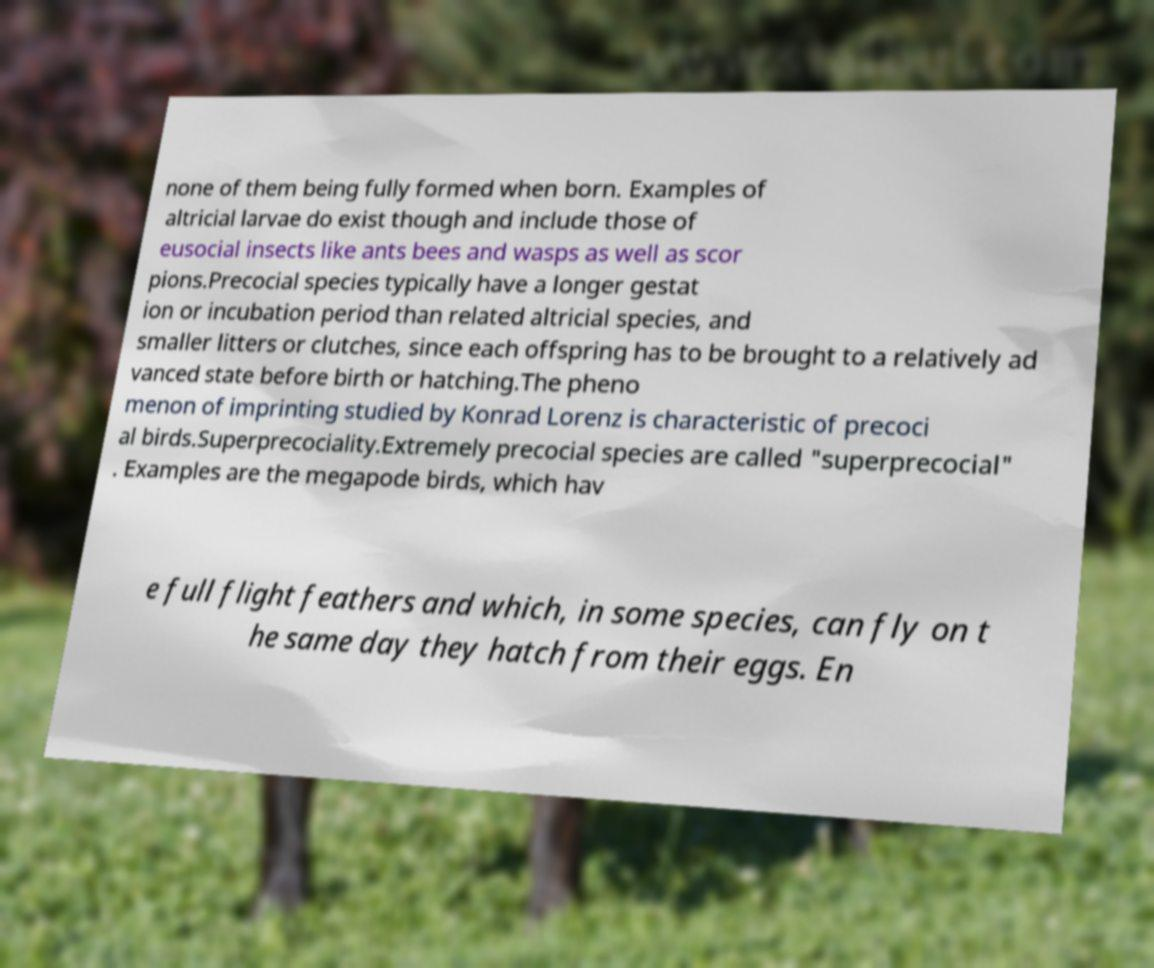Can you accurately transcribe the text from the provided image for me? none of them being fully formed when born. Examples of altricial larvae do exist though and include those of eusocial insects like ants bees and wasps as well as scor pions.Precocial species typically have a longer gestat ion or incubation period than related altricial species, and smaller litters or clutches, since each offspring has to be brought to a relatively ad vanced state before birth or hatching.The pheno menon of imprinting studied by Konrad Lorenz is characteristic of precoci al birds.Superprecociality.Extremely precocial species are called "superprecocial" . Examples are the megapode birds, which hav e full flight feathers and which, in some species, can fly on t he same day they hatch from their eggs. En 